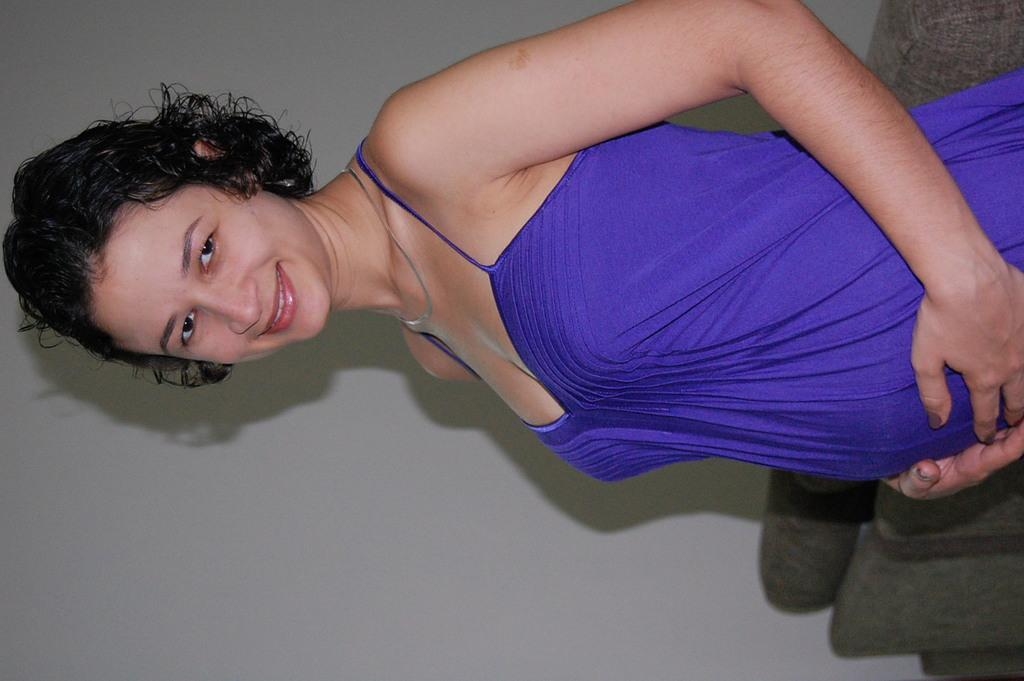Who is present in the image? There is a woman in the image. What is the woman doing in the image? The woman is standing in the image. What is the woman wearing in the image? The woman is wearing a purple dress in the image. What is the woman's facial expression in the image? The woman is smiling in the image. What type of jam is the woman holding in the image? There is no jam present in the image; the woman is not holding anything. 